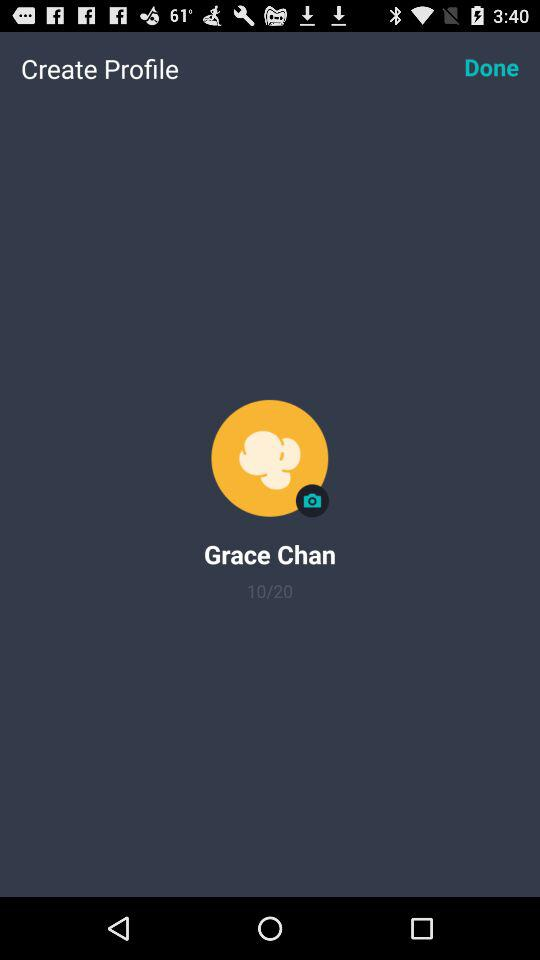How many photos are left for Grace Chan to take?
Answer the question using a single word or phrase. 10 